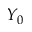<formula> <loc_0><loc_0><loc_500><loc_500>Y _ { 0 }</formula> 